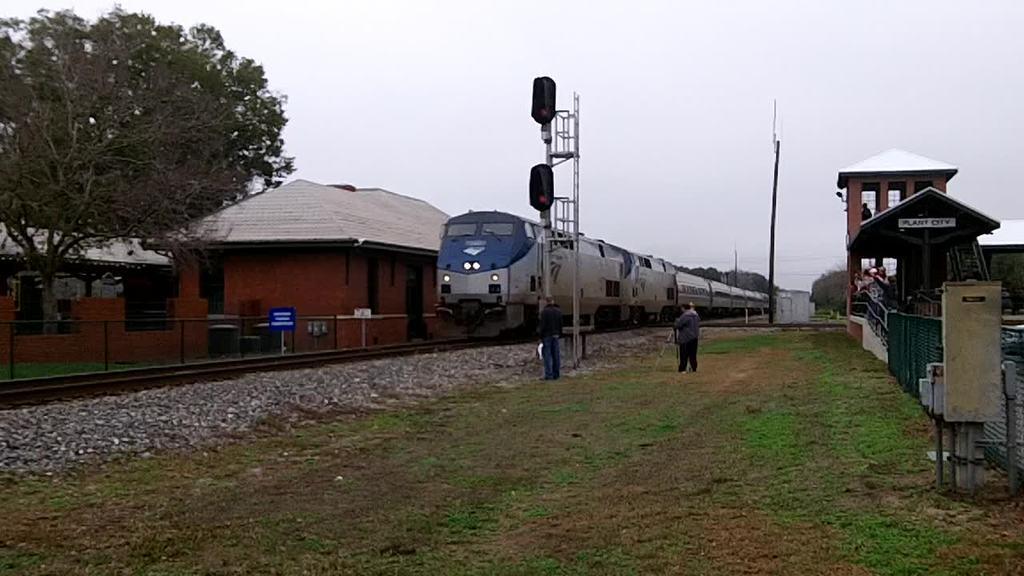In one or two sentences, can you explain what this image depicts? This is an outside view. At the bottom, I can see the grass on the ground. In the middle of the image there is a train on the railway track and also there are few poles. On the left side there are few trees and houses. On the right side there is a building. At the top of the image I can see the sky. In the middle of the image there are two persons standing on the ground facing towards the train. 